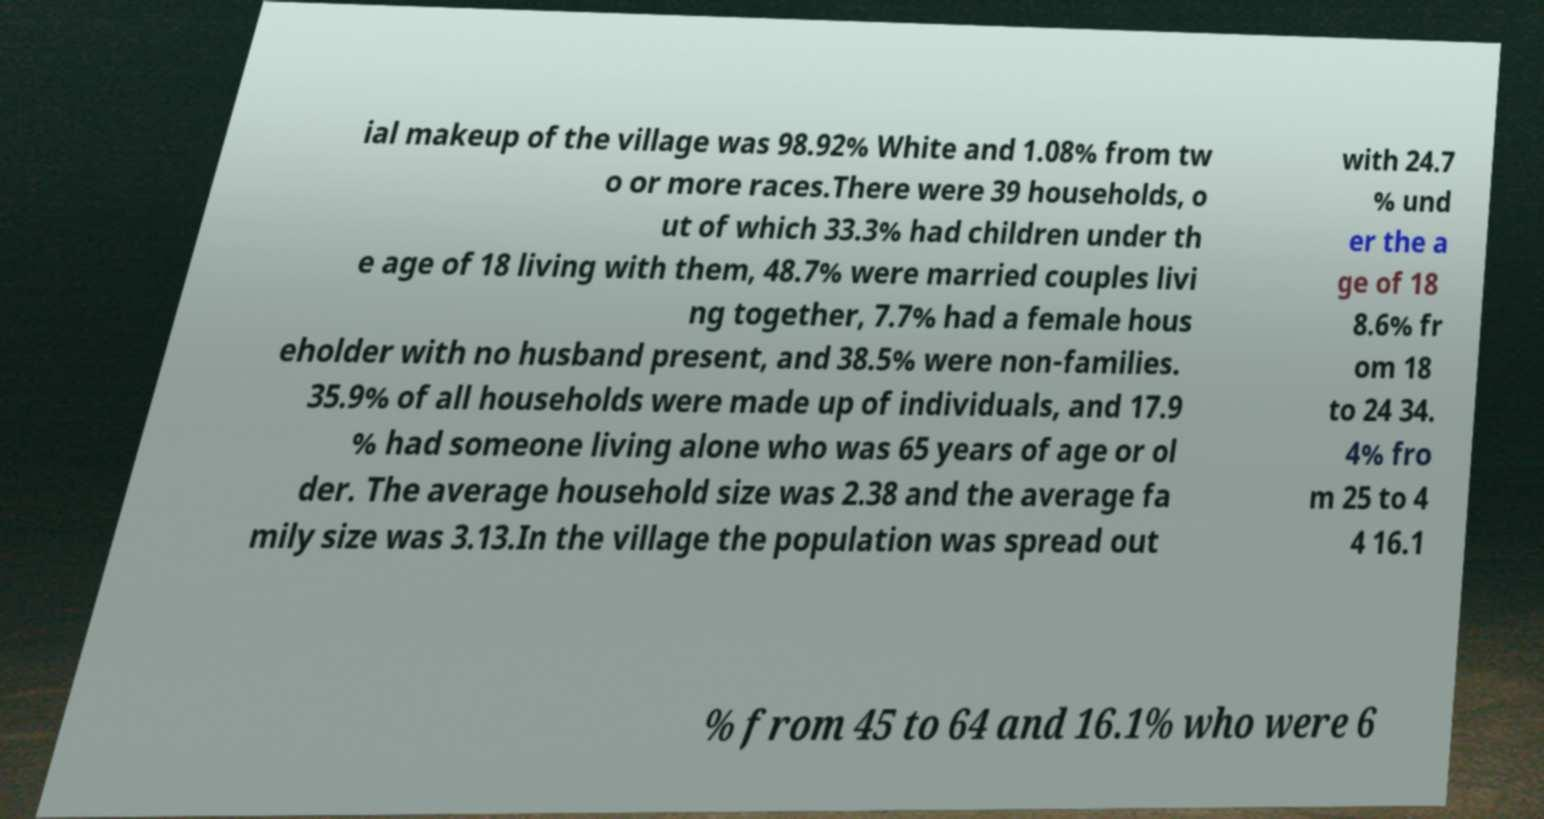There's text embedded in this image that I need extracted. Can you transcribe it verbatim? ial makeup of the village was 98.92% White and 1.08% from tw o or more races.There were 39 households, o ut of which 33.3% had children under th e age of 18 living with them, 48.7% were married couples livi ng together, 7.7% had a female hous eholder with no husband present, and 38.5% were non-families. 35.9% of all households were made up of individuals, and 17.9 % had someone living alone who was 65 years of age or ol der. The average household size was 2.38 and the average fa mily size was 3.13.In the village the population was spread out with 24.7 % und er the a ge of 18 8.6% fr om 18 to 24 34. 4% fro m 25 to 4 4 16.1 % from 45 to 64 and 16.1% who were 6 